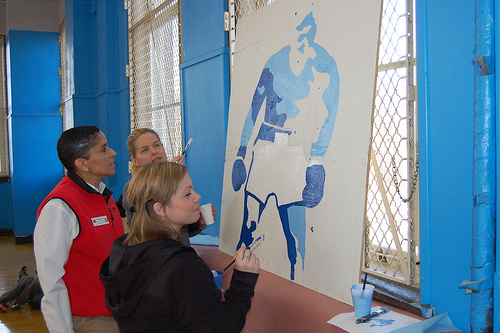<image>
Is the woman behind the window? No. The woman is not behind the window. From this viewpoint, the woman appears to be positioned elsewhere in the scene. 